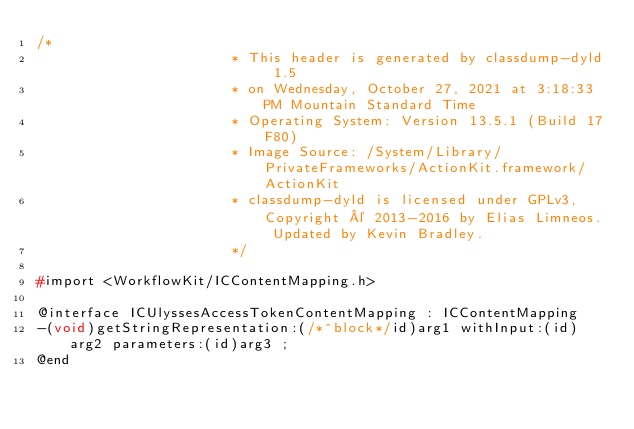<code> <loc_0><loc_0><loc_500><loc_500><_C_>/*
                       * This header is generated by classdump-dyld 1.5
                       * on Wednesday, October 27, 2021 at 3:18:33 PM Mountain Standard Time
                       * Operating System: Version 13.5.1 (Build 17F80)
                       * Image Source: /System/Library/PrivateFrameworks/ActionKit.framework/ActionKit
                       * classdump-dyld is licensed under GPLv3, Copyright © 2013-2016 by Elias Limneos. Updated by Kevin Bradley.
                       */

#import <WorkflowKit/ICContentMapping.h>

@interface ICUlyssesAccessTokenContentMapping : ICContentMapping
-(void)getStringRepresentation:(/*^block*/id)arg1 withInput:(id)arg2 parameters:(id)arg3 ;
@end

</code> 